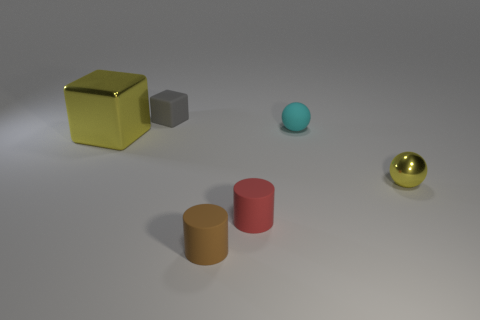Subtract all blocks. How many objects are left? 4 Add 2 tiny cyan spheres. How many objects exist? 8 Subtract all tiny cyan matte balls. Subtract all large metal blocks. How many objects are left? 4 Add 2 tiny rubber blocks. How many tiny rubber blocks are left? 3 Add 2 small purple rubber objects. How many small purple rubber objects exist? 2 Subtract 0 purple balls. How many objects are left? 6 